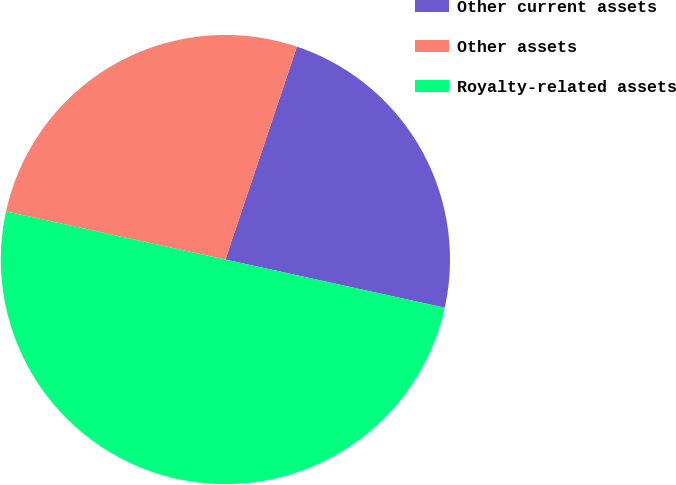<chart> <loc_0><loc_0><loc_500><loc_500><pie_chart><fcel>Other current assets<fcel>Other assets<fcel>Royalty-related assets<nl><fcel>23.28%<fcel>26.72%<fcel>50.0%<nl></chart> 